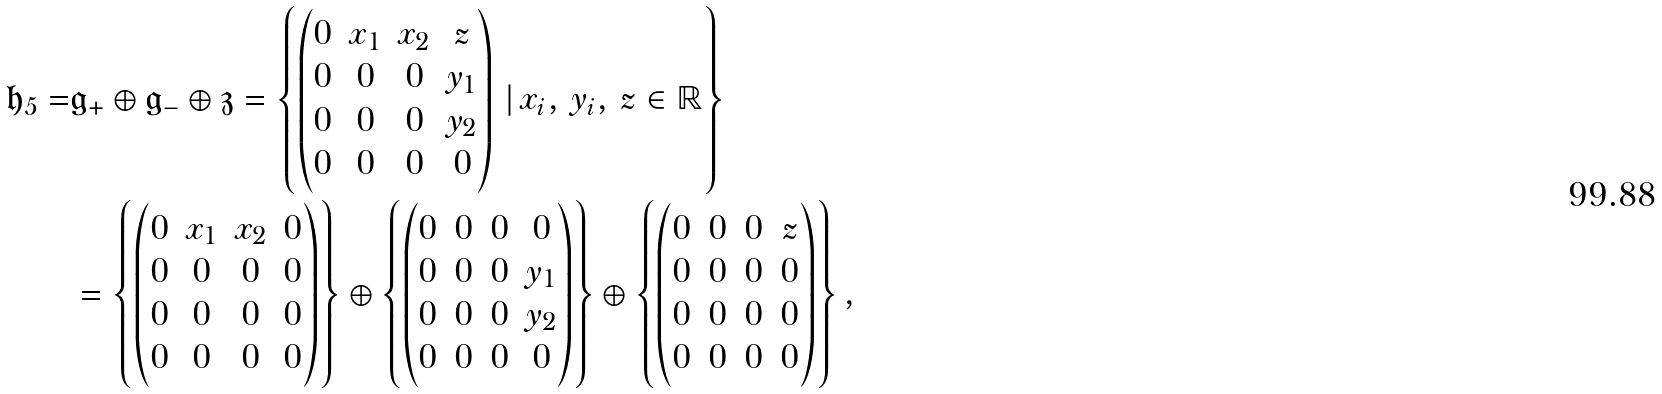<formula> <loc_0><loc_0><loc_500><loc_500>\mathfrak { h } _ { 5 } = & \mathfrak { g } _ { + } \oplus \mathfrak { g } _ { - } \oplus \mathfrak { z } = \left \{ \begin{pmatrix} 0 & x _ { 1 } & x _ { 2 } & z \\ 0 & 0 & 0 & y _ { 1 } \\ 0 & 0 & 0 & y _ { 2 } \\ 0 & 0 & 0 & 0 \\ \end{pmatrix} \, | \, x _ { i } , \, y _ { i } , \, z \in \mathbb { R } \right \} \\ & = \left \{ \begin{pmatrix} 0 & x _ { 1 } & x _ { 2 } & 0 \\ 0 & 0 & 0 & 0 \\ 0 & 0 & 0 & 0 \\ 0 & 0 & 0 & 0 \\ \end{pmatrix} \right \} \oplus \left \{ \begin{pmatrix} 0 & 0 & 0 & 0 \\ 0 & 0 & 0 & y _ { 1 } \\ 0 & 0 & 0 & y _ { 2 } \\ 0 & 0 & 0 & 0 \\ \end{pmatrix} \right \} \oplus \left \{ \begin{pmatrix} 0 & 0 & 0 & z \\ 0 & 0 & 0 & 0 \\ 0 & 0 & 0 & 0 \\ 0 & 0 & 0 & 0 \\ \end{pmatrix} \right \} ,</formula> 